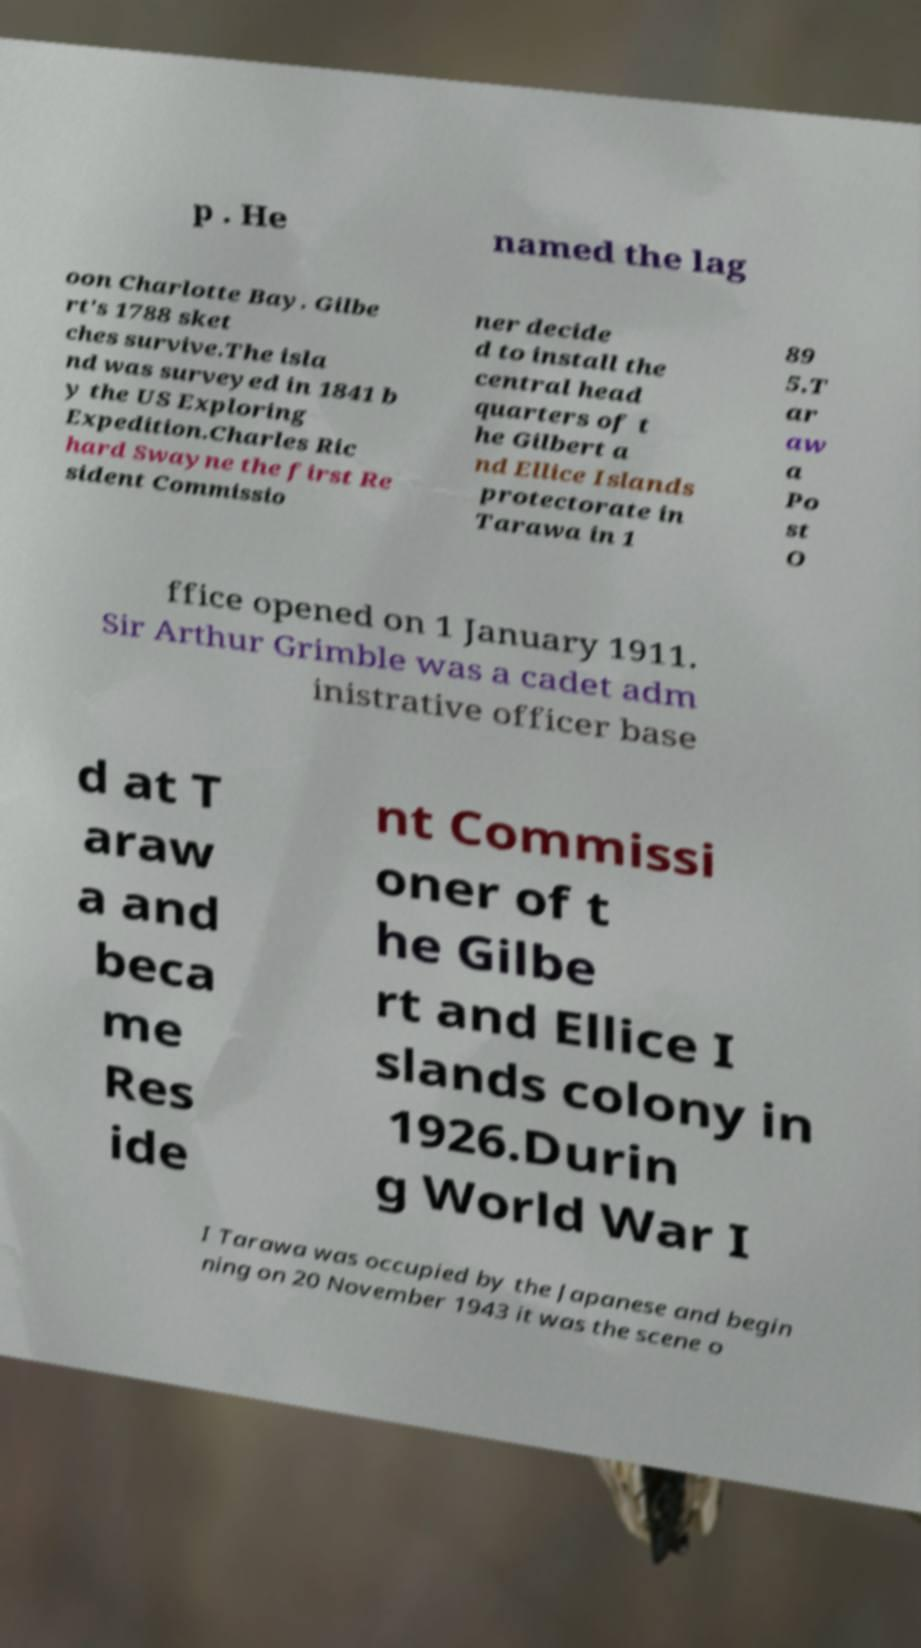Can you accurately transcribe the text from the provided image for me? p . He named the lag oon Charlotte Bay. Gilbe rt's 1788 sket ches survive.The isla nd was surveyed in 1841 b y the US Exploring Expedition.Charles Ric hard Swayne the first Re sident Commissio ner decide d to install the central head quarters of t he Gilbert a nd Ellice Islands protectorate in Tarawa in 1 89 5.T ar aw a Po st O ffice opened on 1 January 1911. Sir Arthur Grimble was a cadet adm inistrative officer base d at T araw a and beca me Res ide nt Commissi oner of t he Gilbe rt and Ellice I slands colony in 1926.Durin g World War I I Tarawa was occupied by the Japanese and begin ning on 20 November 1943 it was the scene o 